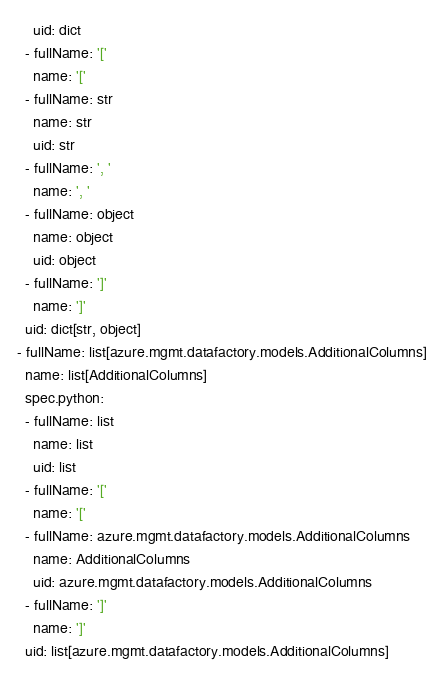Convert code to text. <code><loc_0><loc_0><loc_500><loc_500><_YAML_>    uid: dict
  - fullName: '['
    name: '['
  - fullName: str
    name: str
    uid: str
  - fullName: ', '
    name: ', '
  - fullName: object
    name: object
    uid: object
  - fullName: ']'
    name: ']'
  uid: dict[str, object]
- fullName: list[azure.mgmt.datafactory.models.AdditionalColumns]
  name: list[AdditionalColumns]
  spec.python:
  - fullName: list
    name: list
    uid: list
  - fullName: '['
    name: '['
  - fullName: azure.mgmt.datafactory.models.AdditionalColumns
    name: AdditionalColumns
    uid: azure.mgmt.datafactory.models.AdditionalColumns
  - fullName: ']'
    name: ']'
  uid: list[azure.mgmt.datafactory.models.AdditionalColumns]
</code> 